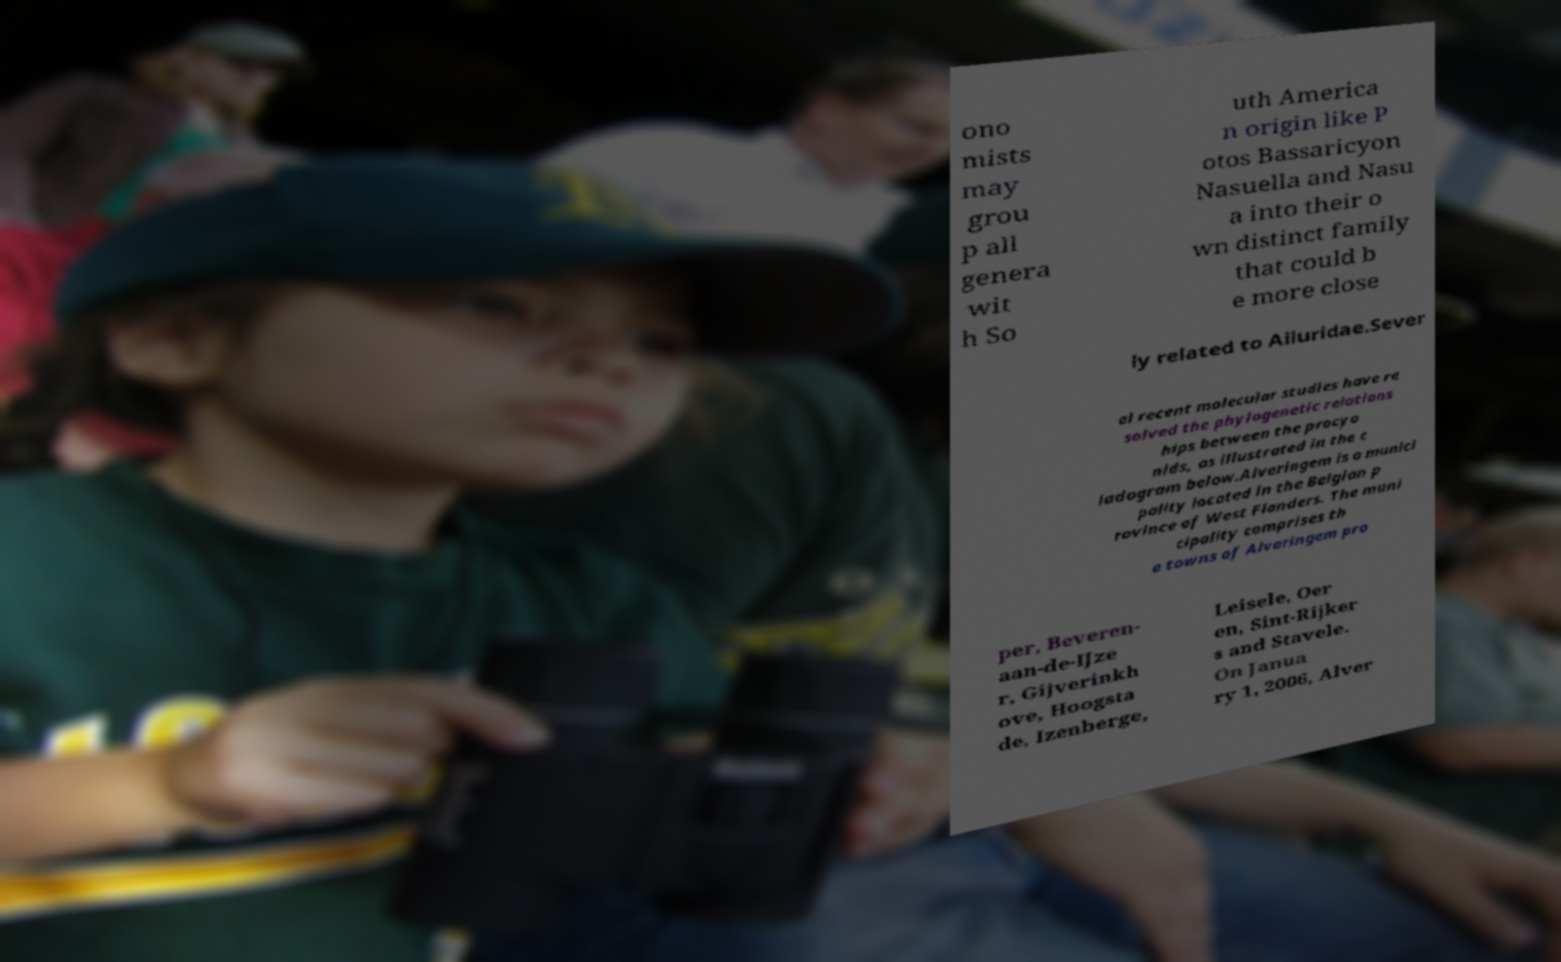What messages or text are displayed in this image? I need them in a readable, typed format. ono mists may grou p all genera wit h So uth America n origin like P otos Bassaricyon Nasuella and Nasu a into their o wn distinct family that could b e more close ly related to Ailuridae.Sever al recent molecular studies have re solved the phylogenetic relations hips between the procyo nids, as illustrated in the c ladogram below.Alveringem is a munici pality located in the Belgian p rovince of West Flanders. The muni cipality comprises th e towns of Alveringem pro per, Beveren- aan-de-IJze r, Gijverinkh ove, Hoogsta de, Izenberge, Leisele, Oer en, Sint-Rijker s and Stavele. On Janua ry 1, 2006, Alver 